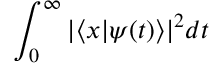Convert formula to latex. <formula><loc_0><loc_0><loc_500><loc_500>\int _ { 0 } ^ { \infty } | \langle x | \psi ( t ) \rangle | ^ { 2 } d t</formula> 